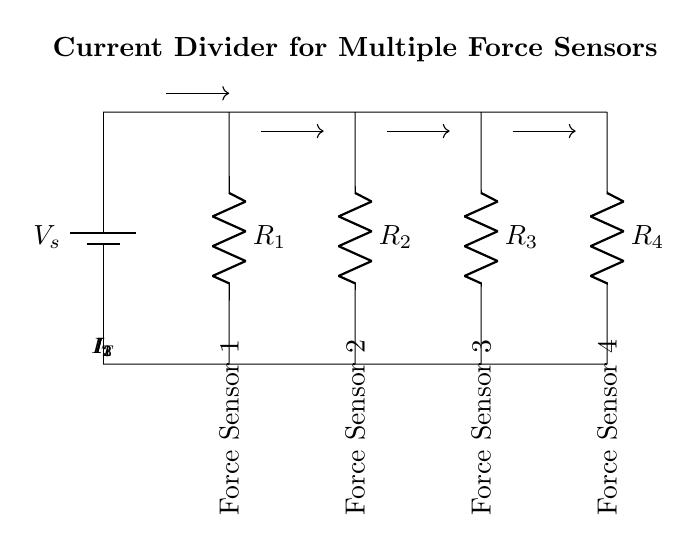What is the total current entering the circuit? The total current \( I_T \) is represented in the circuit diagram for the main current path coming from the power supply. The value isn't specified, but it is labeled clearly.
Answer: \( I_T \) How many force sensors are connected in parallel? The diagram shows four resistors labeled \( R_2 \), \( R_3 \), and \( R_4 \), each corresponding to a force sensor. This indicates there are four force sensors connected in parallel.
Answer: 4 What is the relationship between the total current and the currents through individual sensors? In a current divider, the relationship is defined by the formula \( I_T = I_1 + I_2 + I_3 + I_4 \). Each branch receives a portion of the total current, inversely proportional to their resistance values.
Answer: \( I_T = I_1 + I_2 + I_3 + I_4 \) Which resistance represents Force Sensor 2? The resistor \( R_3 \) represents Force Sensor 2 in the circuit. This can be identified based on the labeling in the diagram and its position relative to the other sensors.
Answer: \( R_3 \) If the resistance values of the sensors are equal, how does the total current distribute among them? When all resistors are equal, the total current divides equally among the branches. Each branch will carry \( I / n \), where \( n \) is the number of resistors, thus each sensor gets the same current. For four equal resistors, each will carry \( I_T / 4 \).
Answer: \( I_T / 4 \) What effect does increasing the resistance of Force Sensor 1 have on the current through it? Increasing the resistance of Force Sensor 1 decreases the current flowing through it, as shown by Ohm's law and the principles of a current divider. Higher resistance results in lower current, following the relationship \( I = V/R \).
Answer: Decreases 